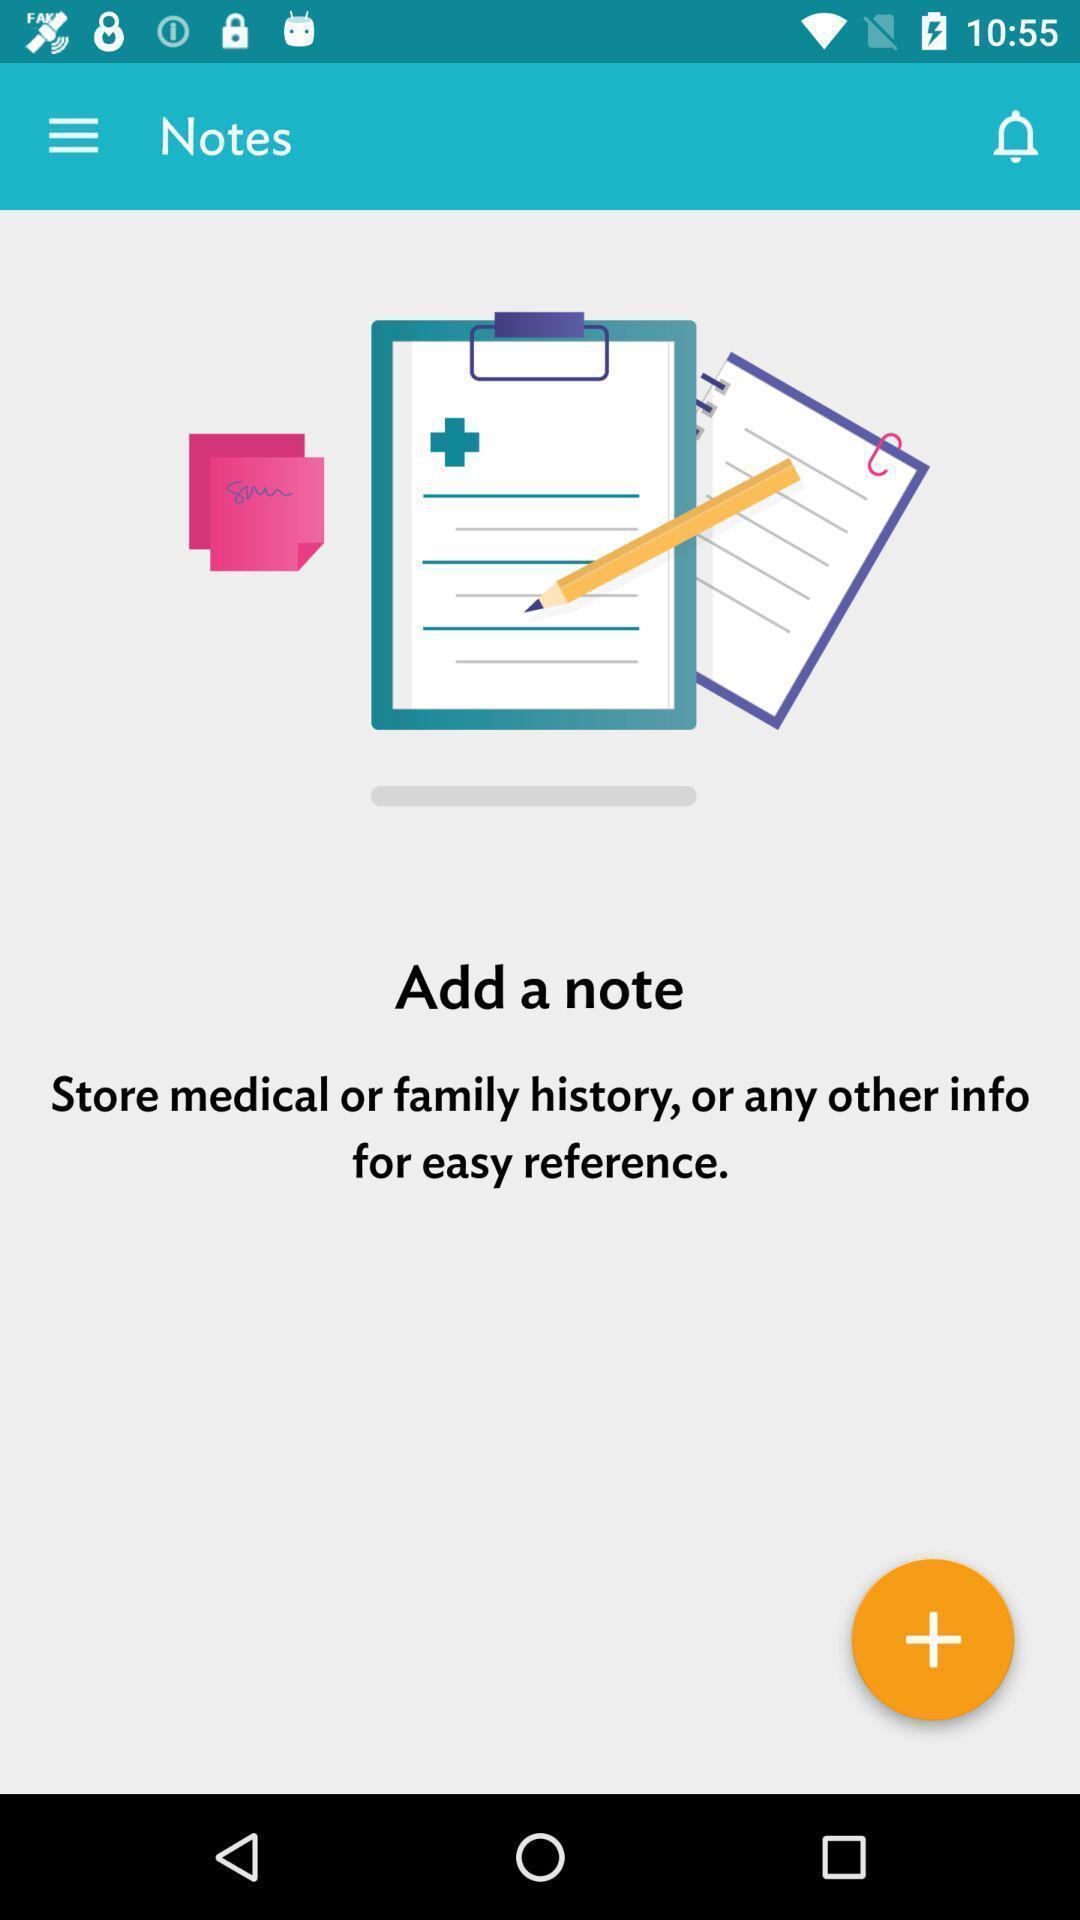Provide a textual representation of this image. Screen shows note details. 